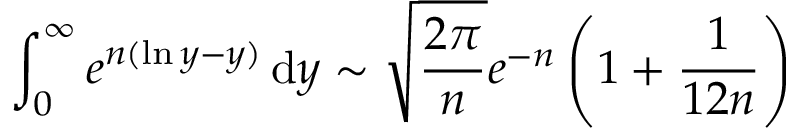<formula> <loc_0><loc_0><loc_500><loc_500>\int _ { 0 } ^ { \infty } e ^ { n ( \ln y - y ) } \, { d } y \sim { \sqrt { \frac { 2 \pi } { n } } } e ^ { - n } \left ( 1 + { \frac { 1 } { 1 2 n } } \right )</formula> 